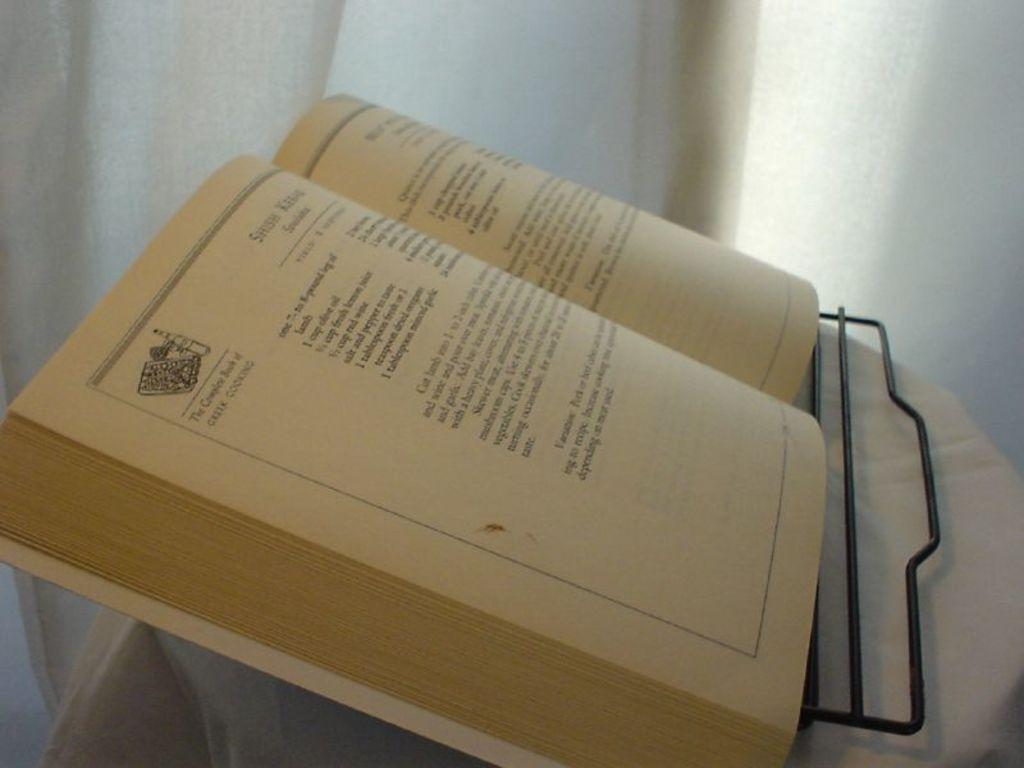<image>
Summarize the visual content of the image. A recipe book called The Complete Book of Greek Cooking 